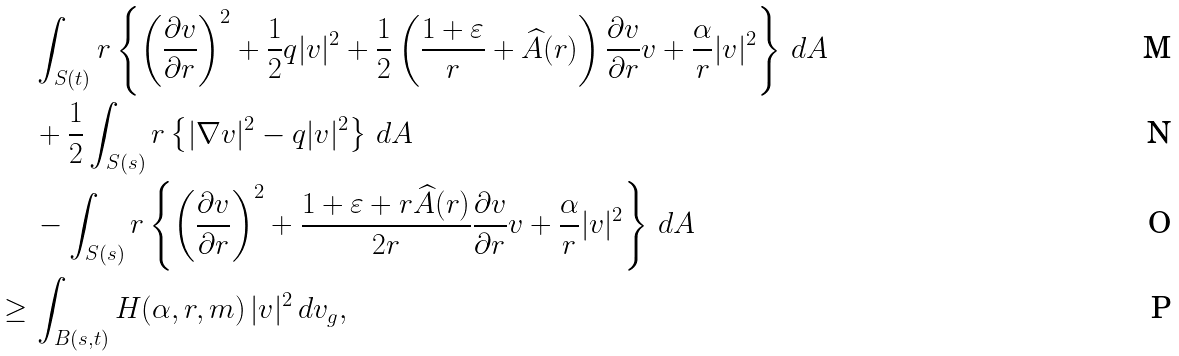Convert formula to latex. <formula><loc_0><loc_0><loc_500><loc_500>& \int _ { S ( t ) } r \left \{ \left ( \frac { \partial v } { \partial r } \right ) ^ { 2 } + \frac { 1 } { 2 } q | v | ^ { 2 } + \frac { 1 } { 2 } \left ( \frac { 1 + \varepsilon } { r } + \widehat { A } ( r ) \right ) \frac { \partial v } { \partial r } v + \frac { \alpha } { r } | v | ^ { 2 } \right \} \, d A \\ & + \frac { 1 } { 2 } \int _ { S ( s ) } r \left \{ | \nabla v | ^ { 2 } - q | v | ^ { 2 } \right \} \, d A \\ & - \int _ { S ( s ) } r \left \{ \left ( \frac { \partial v } { \partial r } \right ) ^ { 2 } + \frac { 1 + \varepsilon + r \widehat { A } ( r ) } { 2 r } \frac { \partial v } { \partial r } v + \frac { \alpha } { r } | v | ^ { 2 } \right \} \, d A \\ \geq \, & \int _ { B ( s , t ) } H ( \alpha , r , m ) \, | v | ^ { 2 } \, d v _ { g } ,</formula> 